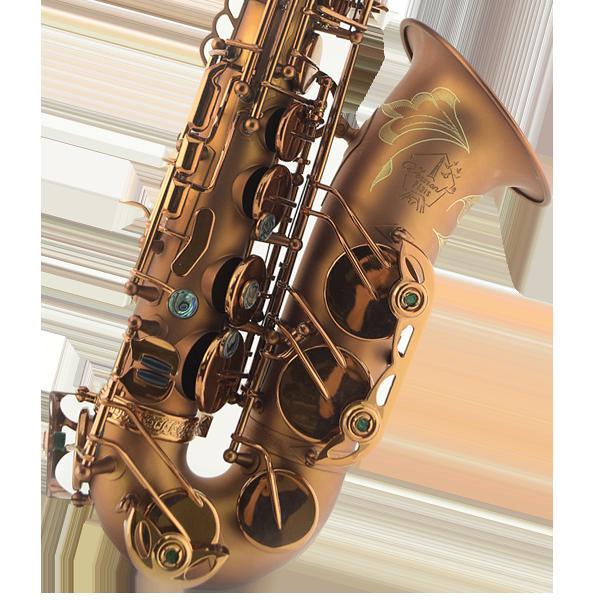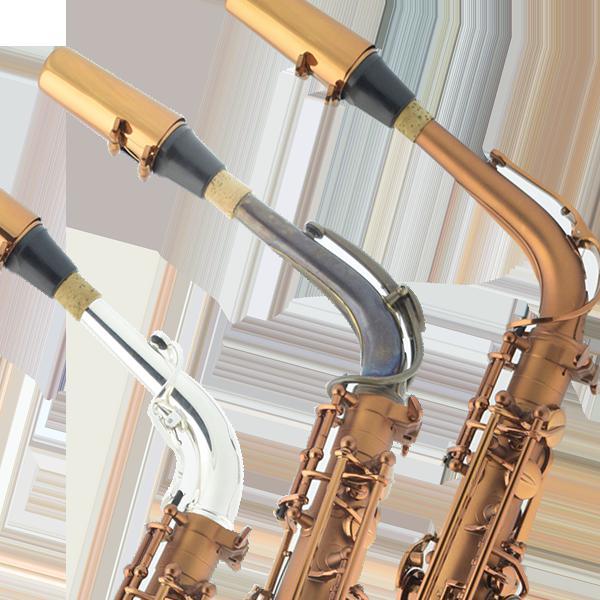The first image is the image on the left, the second image is the image on the right. For the images displayed, is the sentence "An image includes more than one saxophone." factually correct? Answer yes or no. Yes. The first image is the image on the left, the second image is the image on the right. Evaluate the accuracy of this statement regarding the images: "Two saxophones with no musicians are lying down.". Is it true? Answer yes or no. No. 